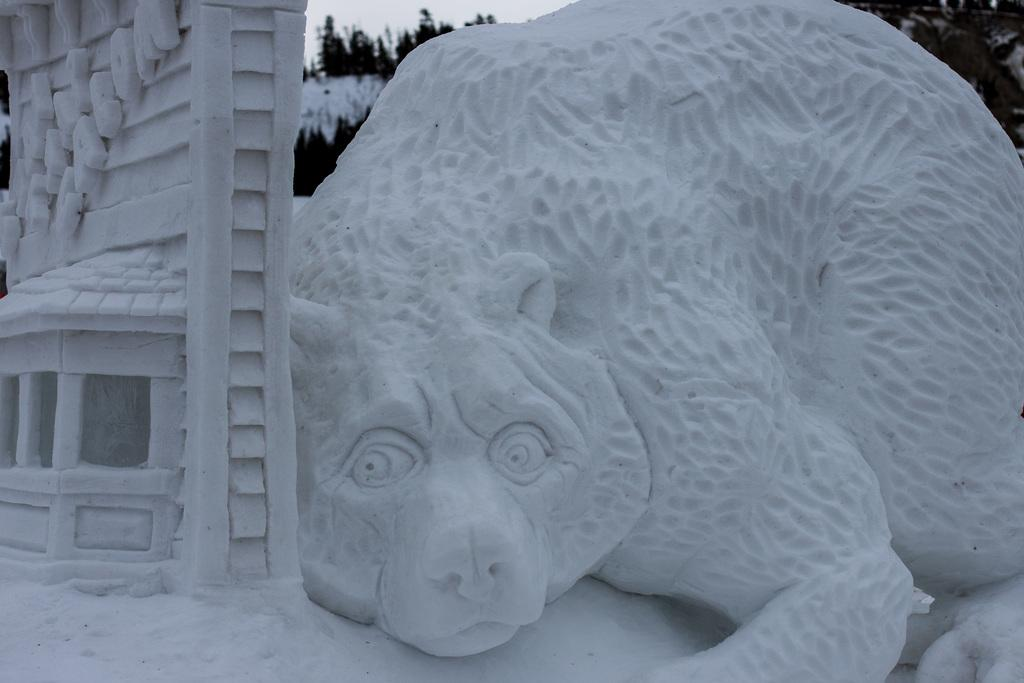What type of art is featured in the image? There is snow art in the image. What can be seen in the background of the image? There are trees and the sky visible in the background of the image. How does the spy use the snow art to communicate in the image? There is no spy present in the image, and the snow art is not being used for communication. 